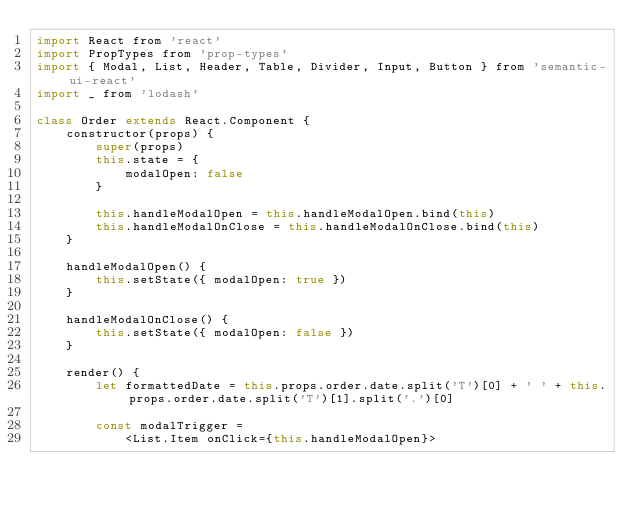<code> <loc_0><loc_0><loc_500><loc_500><_JavaScript_>import React from 'react'
import PropTypes from 'prop-types'
import { Modal, List, Header, Table, Divider, Input, Button } from 'semantic-ui-react'
import _ from 'lodash'

class Order extends React.Component {
    constructor(props) {
        super(props)
        this.state = {
            modalOpen: false
        }

        this.handleModalOpen = this.handleModalOpen.bind(this)
        this.handleModalOnClose = this.handleModalOnClose.bind(this)
    }

    handleModalOpen() {
        this.setState({ modalOpen: true })
    }

    handleModalOnClose() {
        this.setState({ modalOpen: false })
    }

    render() {
        let formattedDate = this.props.order.date.split('T')[0] + ' ' + this.props.order.date.split('T')[1].split('.')[0]

        const modalTrigger =
            <List.Item onClick={this.handleModalOpen}></code> 